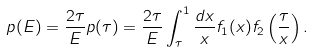<formula> <loc_0><loc_0><loc_500><loc_500>p ( E ) = \frac { 2 \tau } { E } p ( \tau ) = \frac { 2 \tau } { E } \int _ { \tau } ^ { 1 } \frac { d x } { x } f _ { 1 } ( x ) f _ { 2 } \left ( \frac { \tau } { x } \right ) .</formula> 